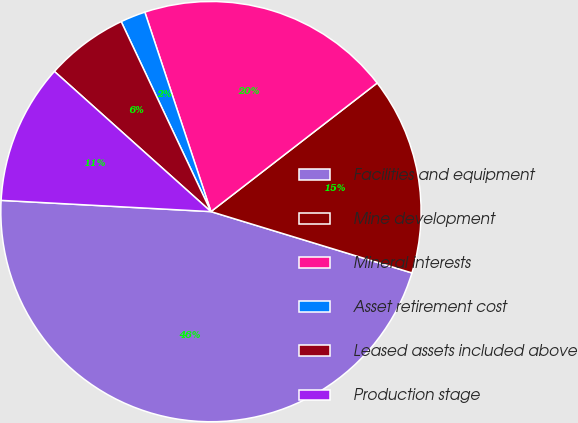Convert chart. <chart><loc_0><loc_0><loc_500><loc_500><pie_chart><fcel>Facilities and equipment<fcel>Mine development<fcel>Mineral interests<fcel>Asset retirement cost<fcel>Leased assets included above<fcel>Production stage<nl><fcel>46.13%<fcel>15.19%<fcel>19.61%<fcel>1.93%<fcel>6.35%<fcel>10.77%<nl></chart> 